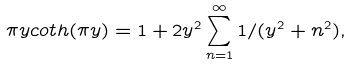<formula> <loc_0><loc_0><loc_500><loc_500>\pi y c o t h ( \pi y ) = 1 + 2 y ^ { 2 } \sum _ { n = 1 } ^ { \infty } 1 / ( y ^ { 2 } + n ^ { 2 } ) ,</formula> 